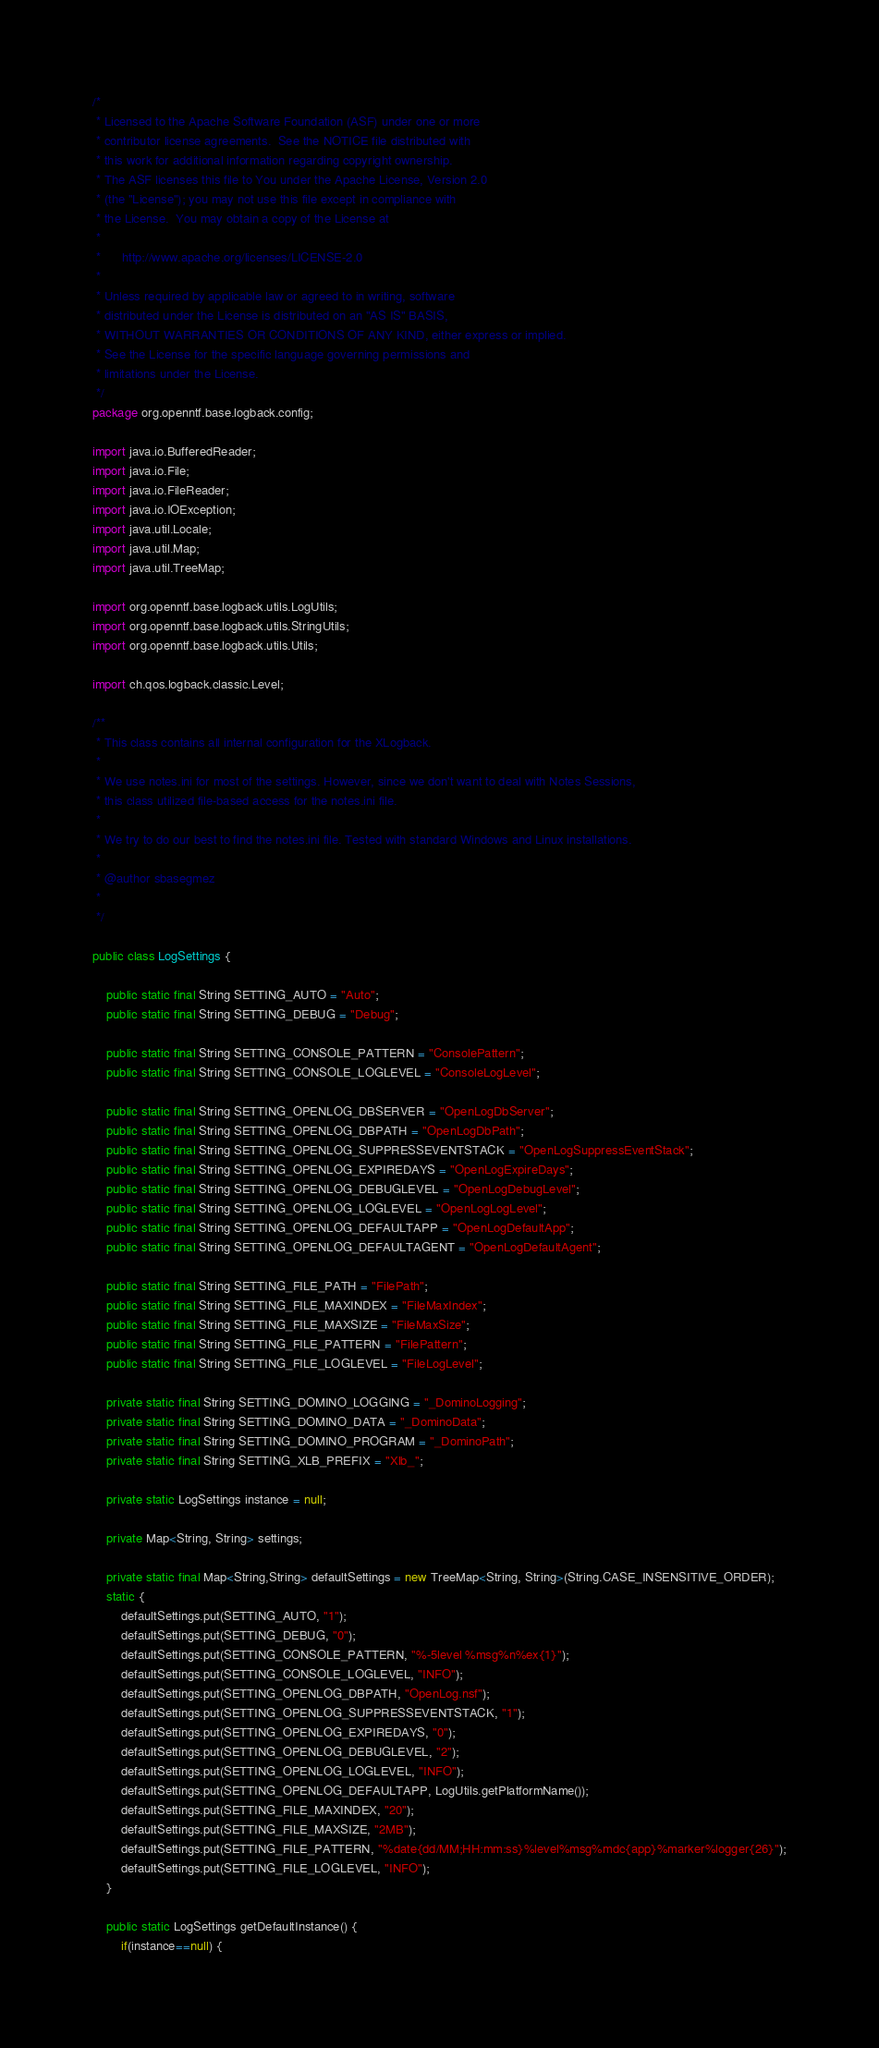Convert code to text. <code><loc_0><loc_0><loc_500><loc_500><_Java_>/*
 * Licensed to the Apache Software Foundation (ASF) under one or more
 * contributor license agreements.  See the NOTICE file distributed with
 * this work for additional information regarding copyright ownership.
 * The ASF licenses this file to You under the Apache License, Version 2.0
 * (the "License"); you may not use this file except in compliance with
 * the License.  You may obtain a copy of the License at
 *
 *      http://www.apache.org/licenses/LICENSE-2.0
 *
 * Unless required by applicable law or agreed to in writing, software
 * distributed under the License is distributed on an "AS IS" BASIS,
 * WITHOUT WARRANTIES OR CONDITIONS OF ANY KIND, either express or implied.
 * See the License for the specific language governing permissions and
 * limitations under the License.
 */
package org.openntf.base.logback.config;

import java.io.BufferedReader;
import java.io.File;
import java.io.FileReader;
import java.io.IOException;
import java.util.Locale;
import java.util.Map;
import java.util.TreeMap;

import org.openntf.base.logback.utils.LogUtils;
import org.openntf.base.logback.utils.StringUtils;
import org.openntf.base.logback.utils.Utils;

import ch.qos.logback.classic.Level;

/**
 * This class contains all internal configuration for the XLogback.
 * 
 * We use notes.ini for most of the settings. However, since we don't want to deal with Notes Sessions,
 * this class utilized file-based access for the notes.ini file.
 *  
 * We try to do our best to find the notes.ini file. Tested with standard Windows and Linux installations.
 * 
 * @author sbasegmez
 *
 */

public class LogSettings {
	
	public static final String SETTING_AUTO = "Auto";
	public static final String SETTING_DEBUG = "Debug";
	
	public static final String SETTING_CONSOLE_PATTERN = "ConsolePattern";
	public static final String SETTING_CONSOLE_LOGLEVEL = "ConsoleLogLevel";
	
	public static final String SETTING_OPENLOG_DBSERVER = "OpenLogDbServer";
	public static final String SETTING_OPENLOG_DBPATH = "OpenLogDbPath";
	public static final String SETTING_OPENLOG_SUPPRESSEVENTSTACK = "OpenLogSuppressEventStack";
	public static final String SETTING_OPENLOG_EXPIREDAYS = "OpenLogExpireDays";
	public static final String SETTING_OPENLOG_DEBUGLEVEL = "OpenLogDebugLevel";
	public static final String SETTING_OPENLOG_LOGLEVEL = "OpenLogLogLevel";
	public static final String SETTING_OPENLOG_DEFAULTAPP = "OpenLogDefaultApp";
	public static final String SETTING_OPENLOG_DEFAULTAGENT = "OpenLogDefaultAgent";

	public static final String SETTING_FILE_PATH = "FilePath";
	public static final String SETTING_FILE_MAXINDEX = "FileMaxIndex";
	public static final String SETTING_FILE_MAXSIZE = "FileMaxSize";
	public static final String SETTING_FILE_PATTERN = "FilePattern";
	public static final String SETTING_FILE_LOGLEVEL = "FileLogLevel";
	
	private static final String SETTING_DOMINO_LOGGING = "_DominoLogging";
	private static final String SETTING_DOMINO_DATA = "_DominoData";
	private static final String SETTING_DOMINO_PROGRAM = "_DominoPath";
	private static final String SETTING_XLB_PREFIX = "Xlb_";
	
	private static LogSettings instance = null;
	
	private Map<String, String> settings;
	
	private static final Map<String,String> defaultSettings = new TreeMap<String, String>(String.CASE_INSENSITIVE_ORDER);
	static {
		defaultSettings.put(SETTING_AUTO, "1");
		defaultSettings.put(SETTING_DEBUG, "0");
		defaultSettings.put(SETTING_CONSOLE_PATTERN, "%-5level %msg%n%ex{1}");
		defaultSettings.put(SETTING_CONSOLE_LOGLEVEL, "INFO");
		defaultSettings.put(SETTING_OPENLOG_DBPATH, "OpenLog.nsf");
		defaultSettings.put(SETTING_OPENLOG_SUPPRESSEVENTSTACK, "1");
		defaultSettings.put(SETTING_OPENLOG_EXPIREDAYS, "0");
		defaultSettings.put(SETTING_OPENLOG_DEBUGLEVEL, "2");
		defaultSettings.put(SETTING_OPENLOG_LOGLEVEL, "INFO");
		defaultSettings.put(SETTING_OPENLOG_DEFAULTAPP, LogUtils.getPlatformName());
		defaultSettings.put(SETTING_FILE_MAXINDEX, "20");
		defaultSettings.put(SETTING_FILE_MAXSIZE, "2MB");
		defaultSettings.put(SETTING_FILE_PATTERN, "%date{dd/MM;HH:mm:ss}%level%msg%mdc{app}%marker%logger{26}");
		defaultSettings.put(SETTING_FILE_LOGLEVEL, "INFO");
	}
	
	public static LogSettings getDefaultInstance() {
		if(instance==null) {</code> 